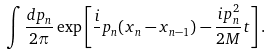Convert formula to latex. <formula><loc_0><loc_0><loc_500><loc_500>\int \frac { d p _ { n } } { 2 \pi } \exp \left [ \frac { i } { } p _ { n } ( x _ { n } - x _ { n - 1 } ) - \frac { i p _ { n } ^ { 2 } } { 2 M } t \right ] .</formula> 